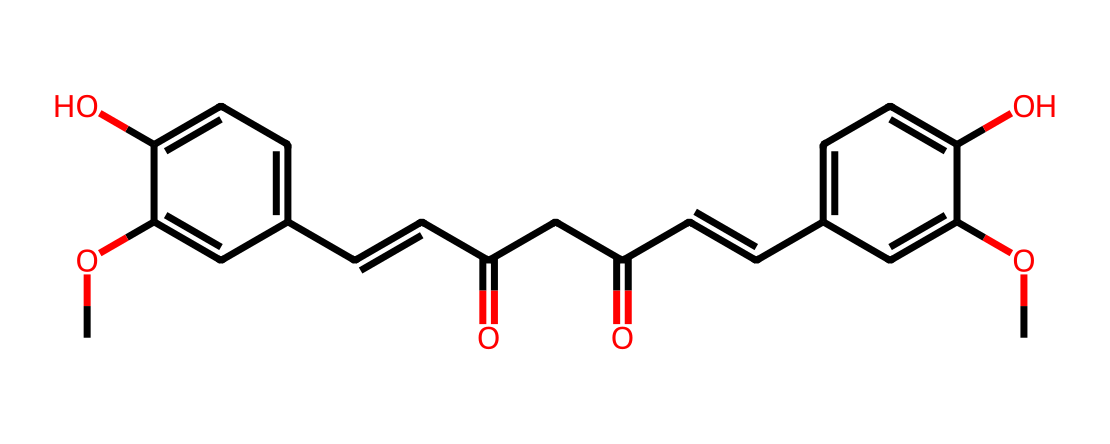What is the molecular formula of curcumin? To determine the molecular formula, we need to count each type of atom present in the provided SMILES representation. From the structure, we can identify carbon (C), hydrogen (H), and oxygen (O) atoms. By analyzing the SMILES string, we find 21 carbon atoms, 20 hydrogen atoms, and 6 oxygen atoms, which gives the molecular formula C21H20O6.
Answer: C21H20O6 How many hydroxyl groups are present in curcumin? The SMILES representation shows two 'O' atoms in -OH (hydroxyl) groups attached to the aromatic rings, identifiable by the 'c' notation followed by 'O'. Counting these, we find there are two hydroxyl groups in the structure.
Answer: 2 What type of chemical structure is curcumin classified as? Curcumin is primarily a type of polyphenolic compound because of the phenolic -OH groups present in the structure. The presence of multiple aromatic rings and the functional groups characteristic of polyphenols confirms this classification.
Answer: polyphenol What is the highest degree of unsaturation in curcumin's structure? The degree of unsaturation can be calculated by counting the number of rings and multiple bonds in the structure. Curcumin has two double bonds (C=C) and does not contain any cycles, which contributes to its degree of unsaturation. Thus, the total degree of unsaturation is 4.
Answer: 4 How many total rings are present in curcumin? By analyzing the structure, we can note there are no complete cyclic structures, but there are two aromatic rings present, indicated by the 'ccc' notations in the SMILES. Therefore, we can conclude there are two distinct aromatic rings in curcumin.
Answer: 2 What functional groups are found in curcumin? The functional groups present in curcumin include hydroxyl (-OH) groups and carbonyl (C=O) groups. By examining the SMILES, we can identify these groups through the 'O' and '=' notations, affirming both are present in the structure.
Answer: hydroxyl and carbonyl 